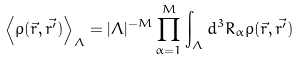<formula> <loc_0><loc_0><loc_500><loc_500>\left \langle \rho ( \vec { r } , \vec { r ^ { \prime } } ) \right \rangle _ { \Lambda } = | \Lambda | ^ { - M } \prod _ { \alpha = 1 } ^ { M } \int _ { \Lambda } d ^ { 3 } R _ { \alpha } \rho ( \vec { r } , \vec { r ^ { \prime } } )</formula> 